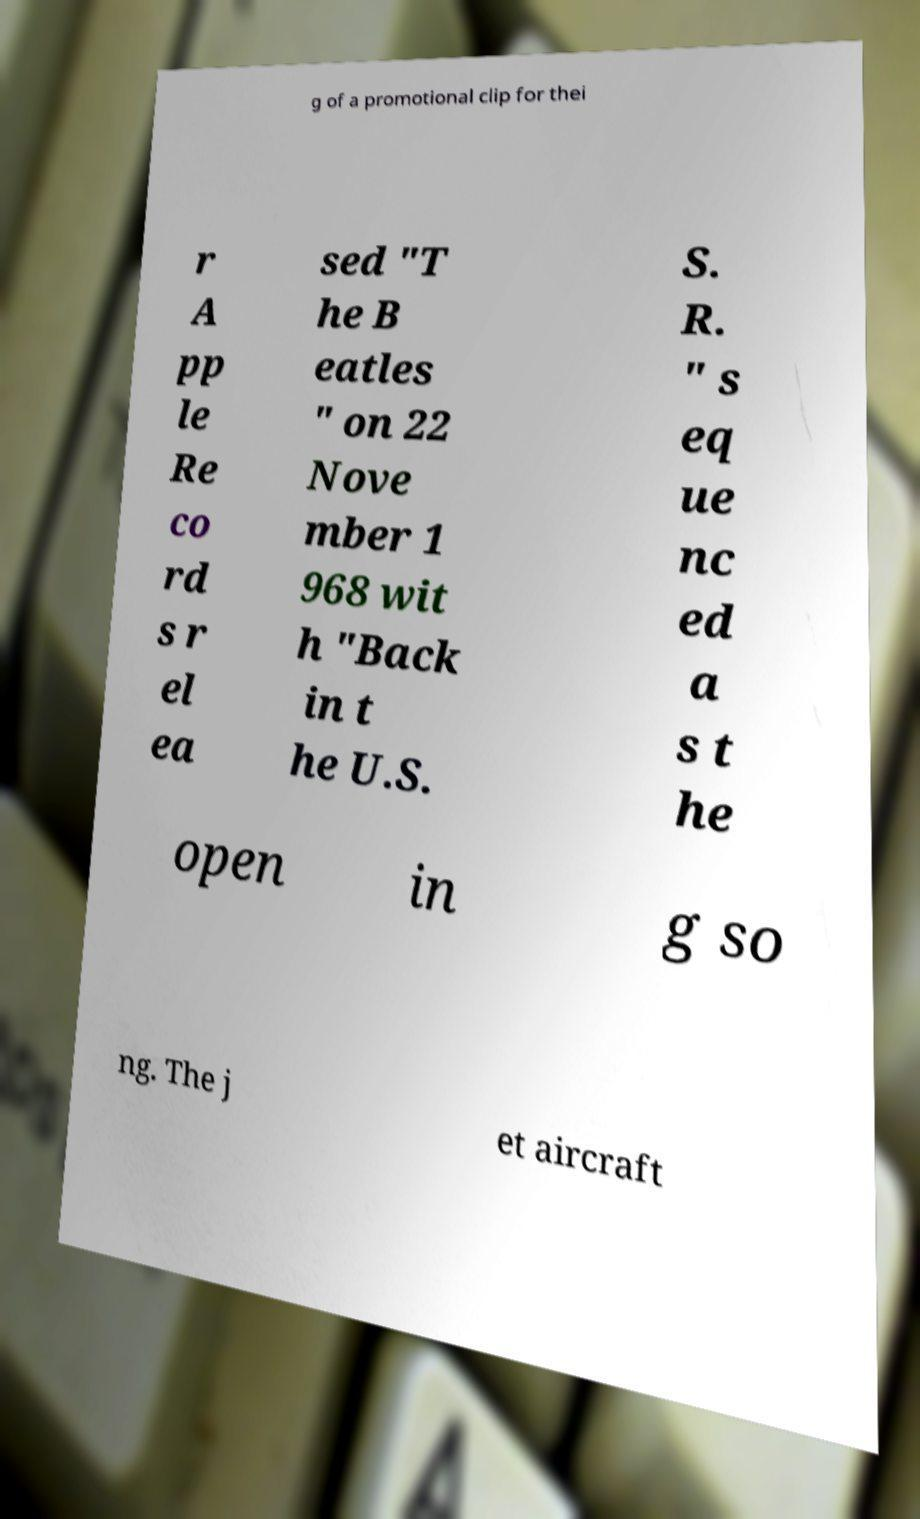Please identify and transcribe the text found in this image. g of a promotional clip for thei r A pp le Re co rd s r el ea sed "T he B eatles " on 22 Nove mber 1 968 wit h "Back in t he U.S. S. R. " s eq ue nc ed a s t he open in g so ng. The j et aircraft 